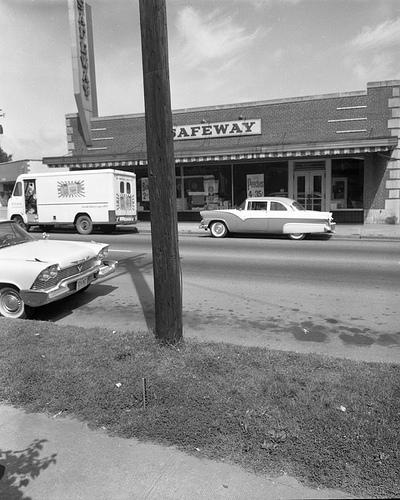How many cars are in the picture?
Short answer required. 3. Is there a supermarket in the picture?
Keep it brief. Yes. What year is the car?
Keep it brief. 1950. Is the van legally parked?
Concise answer only. Yes. Is the picture in color?
Write a very short answer. No. 